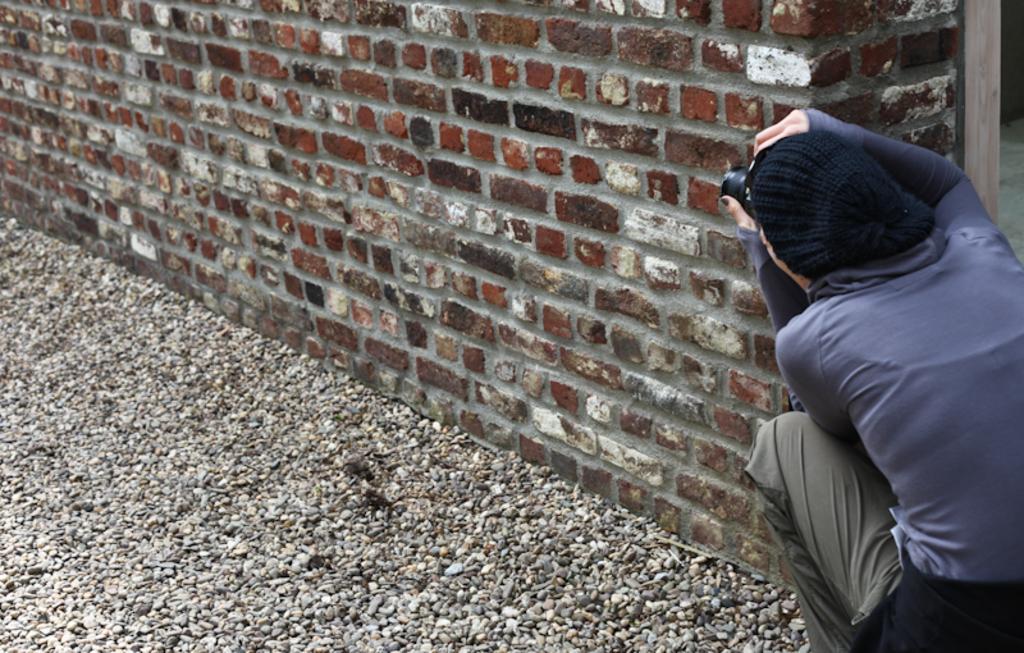Could you give a brief overview of what you see in this image? In this image I can see a person wearing blue, black and grey colored dress is sitting and holding a camera. I can see small stones on the ground and the wall which is made up of bricks. 